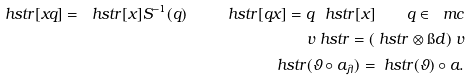Convert formula to latex. <formula><loc_0><loc_0><loc_500><loc_500>\ h s t r [ x q ] = \ h s t r [ x ] S ^ { - 1 } ( q ) \quad \ h s t r [ q x ] = q \ h s t r [ x ] \quad q \in \ m c \\ \ v \ h s t r = ( \ h s t r \otimes \i d ) \ v \\ \ h s t r ( \vartheta \circ a _ { \lambda } ) = \ h s t r ( \vartheta ) \circ a .</formula> 